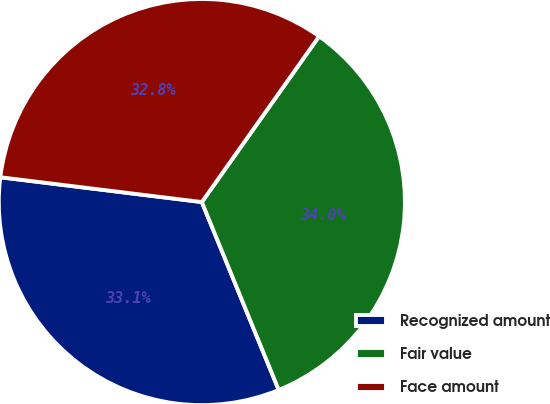<chart> <loc_0><loc_0><loc_500><loc_500><pie_chart><fcel>Recognized amount<fcel>Fair value<fcel>Face amount<nl><fcel>33.13%<fcel>34.02%<fcel>32.85%<nl></chart> 